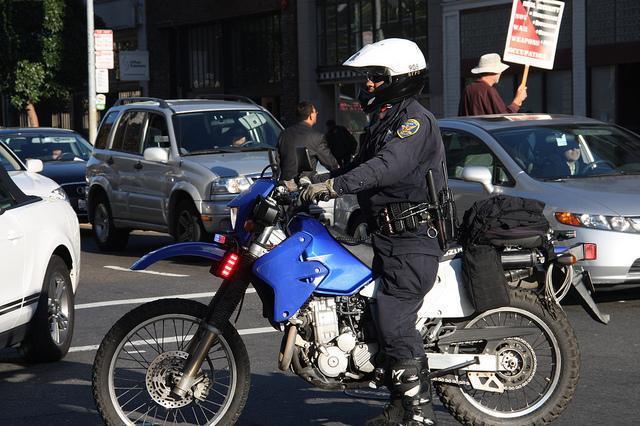How many cars are in the photo?
Give a very brief answer. 4. How many people are there?
Give a very brief answer. 3. How many white horses are pulling the carriage?
Give a very brief answer. 0. 